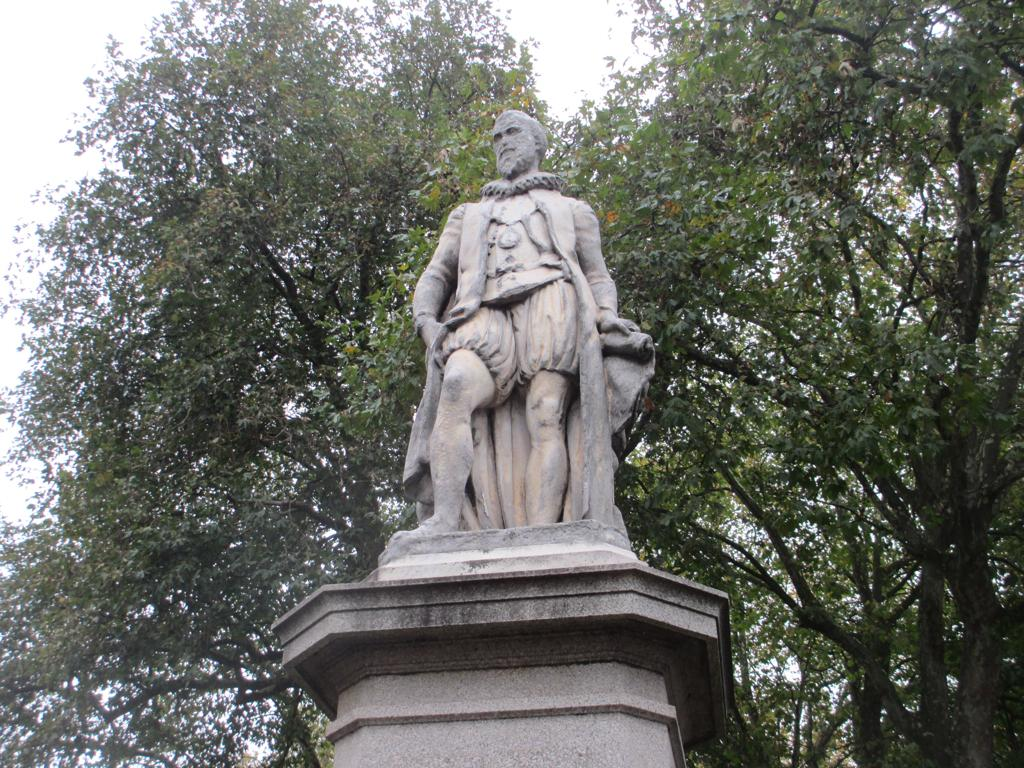What is the main subject in the image? There is a statue in the image. What can be seen in the background of the image? There are trees in the background of the image. What type of farm animals can be seen grazing on the side of the statue in the image? There are no farm animals or any indication of a farm in the image; it only features a statue and trees in the background. 